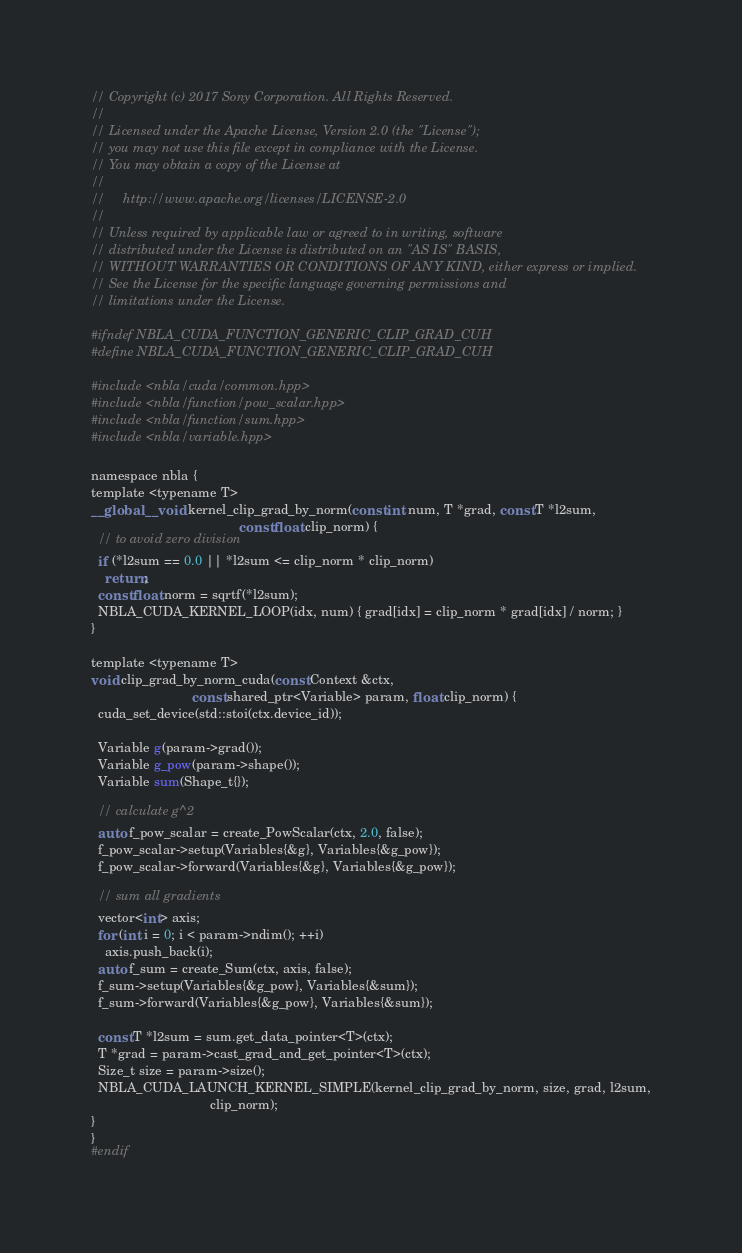<code> <loc_0><loc_0><loc_500><loc_500><_Cuda_>// Copyright (c) 2017 Sony Corporation. All Rights Reserved.
//
// Licensed under the Apache License, Version 2.0 (the "License");
// you may not use this file except in compliance with the License.
// You may obtain a copy of the License at
//
//     http://www.apache.org/licenses/LICENSE-2.0
//
// Unless required by applicable law or agreed to in writing, software
// distributed under the License is distributed on an "AS IS" BASIS,
// WITHOUT WARRANTIES OR CONDITIONS OF ANY KIND, either express or implied.
// See the License for the specific language governing permissions and
// limitations under the License.

#ifndef NBLA_CUDA_FUNCTION_GENERIC_CLIP_GRAD_CUH
#define NBLA_CUDA_FUNCTION_GENERIC_CLIP_GRAD_CUH

#include <nbla/cuda/common.hpp>
#include <nbla/function/pow_scalar.hpp>
#include <nbla/function/sum.hpp>
#include <nbla/variable.hpp>

namespace nbla {
template <typename T>
__global__ void kernel_clip_grad_by_norm(const int num, T *grad, const T *l2sum,
                                         const float clip_norm) {
  // to avoid zero division
  if (*l2sum == 0.0 || *l2sum <= clip_norm * clip_norm)
    return;
  const float norm = sqrtf(*l2sum);
  NBLA_CUDA_KERNEL_LOOP(idx, num) { grad[idx] = clip_norm * grad[idx] / norm; }
}

template <typename T>
void clip_grad_by_norm_cuda(const Context &ctx,
                            const shared_ptr<Variable> param, float clip_norm) {
  cuda_set_device(std::stoi(ctx.device_id));

  Variable g(param->grad());
  Variable g_pow(param->shape());
  Variable sum(Shape_t{});

  // calculate g^2
  auto f_pow_scalar = create_PowScalar(ctx, 2.0, false);
  f_pow_scalar->setup(Variables{&g}, Variables{&g_pow});
  f_pow_scalar->forward(Variables{&g}, Variables{&g_pow});

  // sum all gradients
  vector<int> axis;
  for (int i = 0; i < param->ndim(); ++i)
    axis.push_back(i);
  auto f_sum = create_Sum(ctx, axis, false);
  f_sum->setup(Variables{&g_pow}, Variables{&sum});
  f_sum->forward(Variables{&g_pow}, Variables{&sum});

  const T *l2sum = sum.get_data_pointer<T>(ctx);
  T *grad = param->cast_grad_and_get_pointer<T>(ctx);
  Size_t size = param->size();
  NBLA_CUDA_LAUNCH_KERNEL_SIMPLE(kernel_clip_grad_by_norm, size, grad, l2sum,
                                 clip_norm);
}
}
#endif
</code> 